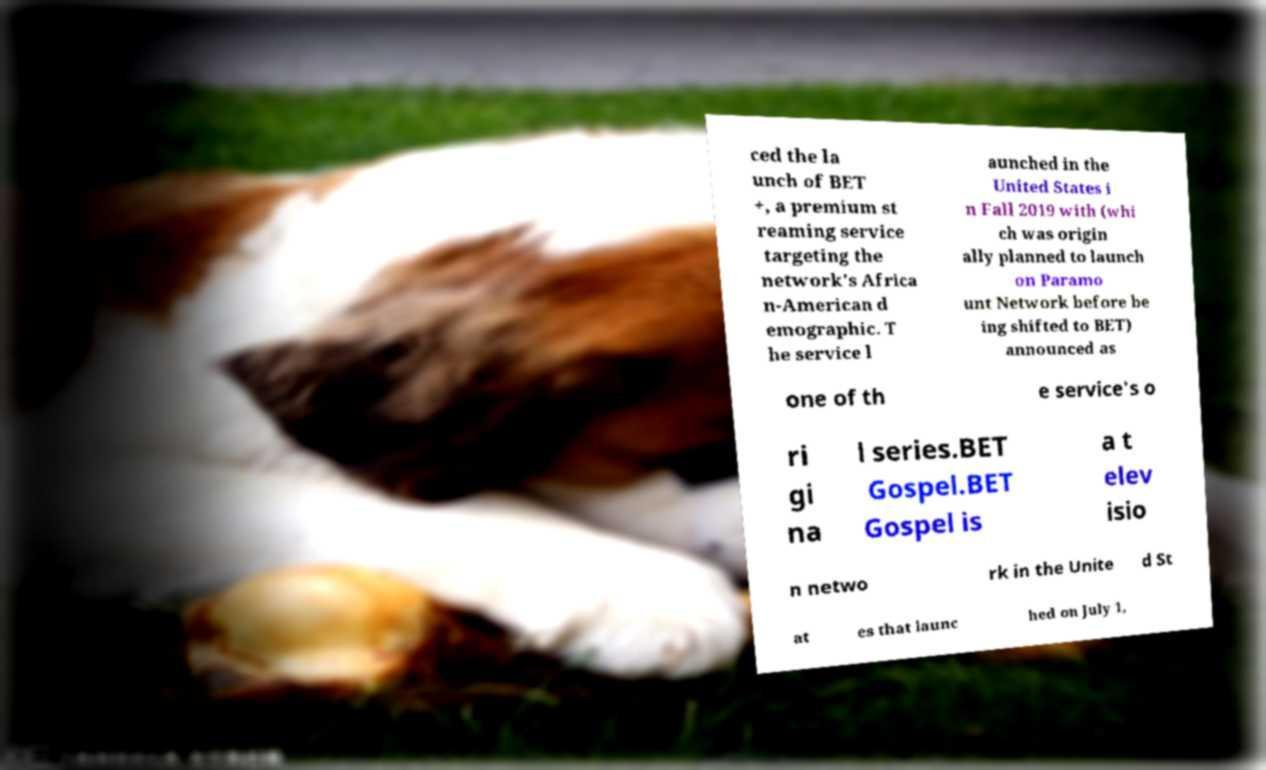There's text embedded in this image that I need extracted. Can you transcribe it verbatim? ced the la unch of BET +, a premium st reaming service targeting the network's Africa n-American d emographic. T he service l aunched in the United States i n Fall 2019 with (whi ch was origin ally planned to launch on Paramo unt Network before be ing shifted to BET) announced as one of th e service's o ri gi na l series.BET Gospel.BET Gospel is a t elev isio n netwo rk in the Unite d St at es that launc hed on July 1, 